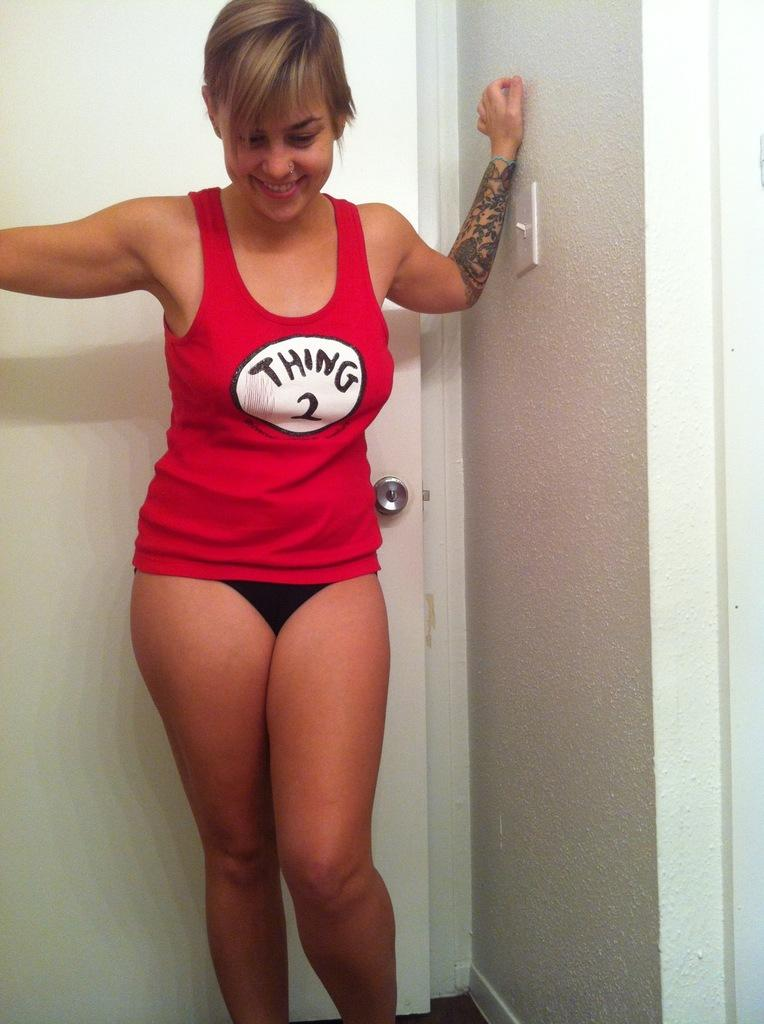Who is in the picture? There is a woman in the picture. What is the woman wearing? The woman is wearing a t-shirt and shorts. Where is the woman standing in relation to the door? The woman is standing near a door. What can be seen on the right side of the image? There is a wall visible on the right side of the image. What is the purpose of the scale in the image? There is no scale present in the image. 